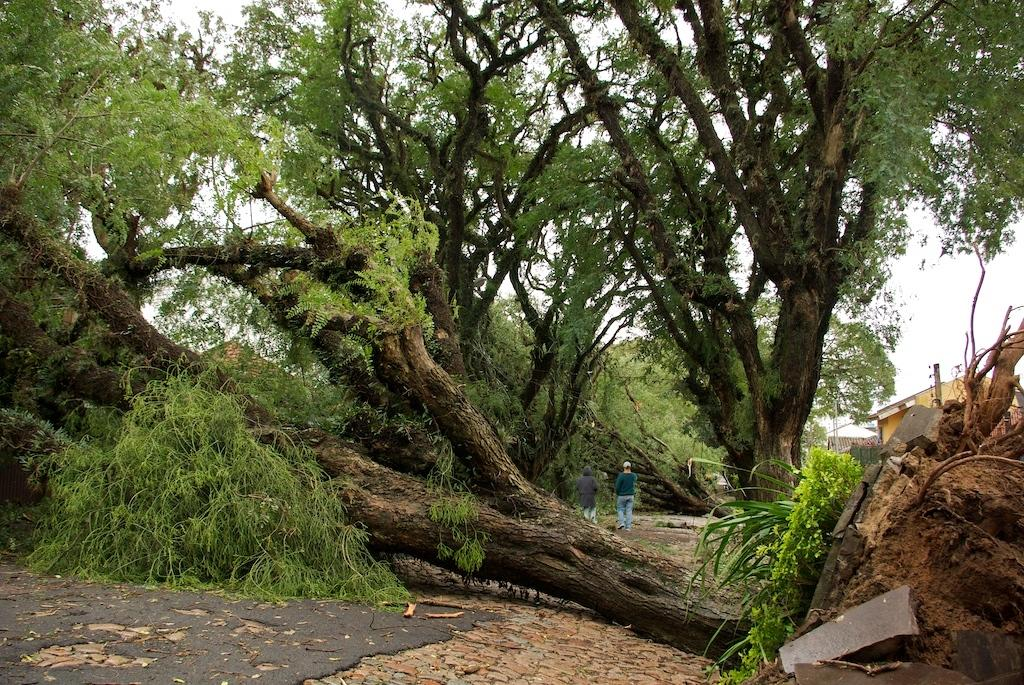How many people are in the image? There are two people in the image. What are the people doing in the image? The people are on a path. What can be seen in front of the people? There are trees and houses in front of the people. What is visible in the background of the image? The sky is visible in the image. What type of knife is being used to cut the soda in the image? There is no knife or soda present in the image. Is there a tent visible in the image? No, there is no tent visible in the image. 